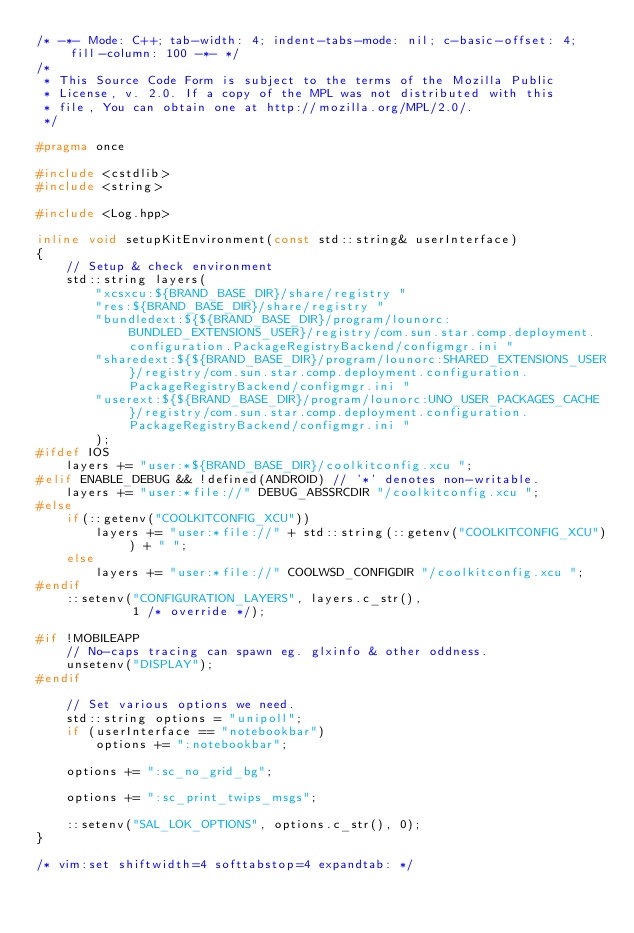Convert code to text. <code><loc_0><loc_0><loc_500><loc_500><_C++_>/* -*- Mode: C++; tab-width: 4; indent-tabs-mode: nil; c-basic-offset: 4; fill-column: 100 -*- */
/*
 * This Source Code Form is subject to the terms of the Mozilla Public
 * License, v. 2.0. If a copy of the MPL was not distributed with this
 * file, You can obtain one at http://mozilla.org/MPL/2.0/.
 */

#pragma once

#include <cstdlib>
#include <string>

#include <Log.hpp>

inline void setupKitEnvironment(const std::string& userInterface)
{
    // Setup & check environment
    std::string layers(
        "xcsxcu:${BRAND_BASE_DIR}/share/registry "
        "res:${BRAND_BASE_DIR}/share/registry "
        "bundledext:${${BRAND_BASE_DIR}/program/lounorc:BUNDLED_EXTENSIONS_USER}/registry/com.sun.star.comp.deployment.configuration.PackageRegistryBackend/configmgr.ini "
        "sharedext:${${BRAND_BASE_DIR}/program/lounorc:SHARED_EXTENSIONS_USER}/registry/com.sun.star.comp.deployment.configuration.PackageRegistryBackend/configmgr.ini "
        "userext:${${BRAND_BASE_DIR}/program/lounorc:UNO_USER_PACKAGES_CACHE}/registry/com.sun.star.comp.deployment.configuration.PackageRegistryBackend/configmgr.ini "
        );
#ifdef IOS
    layers += "user:*${BRAND_BASE_DIR}/coolkitconfig.xcu ";
#elif ENABLE_DEBUG && !defined(ANDROID) // '*' denotes non-writable.
    layers += "user:*file://" DEBUG_ABSSRCDIR "/coolkitconfig.xcu ";
#else
    if(::getenv("COOLKITCONFIG_XCU"))
        layers += "user:*file://" + std::string(::getenv("COOLKITCONFIG_XCU")) + " ";
    else
        layers += "user:*file://" COOLWSD_CONFIGDIR "/coolkitconfig.xcu ";
#endif
    ::setenv("CONFIGURATION_LAYERS", layers.c_str(),
             1 /* override */);

#if !MOBILEAPP
    // No-caps tracing can spawn eg. glxinfo & other oddness.
    unsetenv("DISPLAY");
#endif

    // Set various options we need.
    std::string options = "unipoll";
    if (userInterface == "notebookbar")
        options += ":notebookbar";

    options += ":sc_no_grid_bg";

    options += ":sc_print_twips_msgs";

    ::setenv("SAL_LOK_OPTIONS", options.c_str(), 0);
}

/* vim:set shiftwidth=4 softtabstop=4 expandtab: */
</code> 